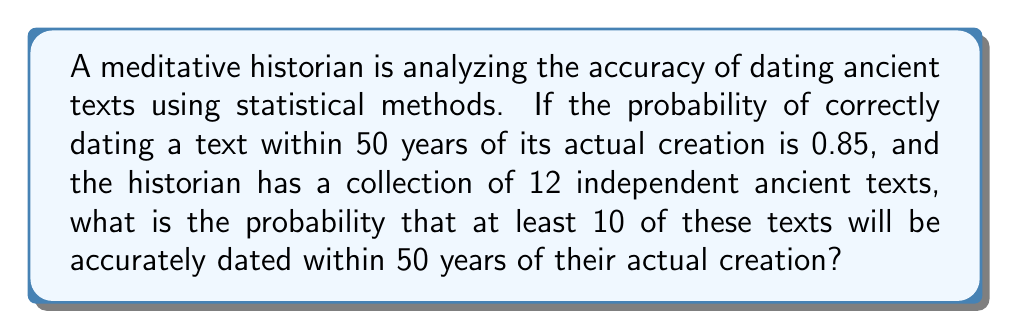Solve this math problem. Let's approach this step-by-step:

1) We can model this situation using a binomial distribution, where:
   - $n = 12$ (number of texts)
   - $p = 0.85$ (probability of success for each text)
   - We want to find $P(X \geq 10)$, where $X$ is the number of accurately dated texts

2) The probability of at least 10 successes is equal to 1 minus the probability of 9 or fewer successes:

   $P(X \geq 10) = 1 - P(X \leq 9)$

3) We can calculate this using the cumulative binomial probability function:

   $P(X \geq 10) = 1 - \sum_{k=0}^9 \binom{12}{k} (0.85)^k (0.15)^{12-k}$

4) Let's calculate this step-by-step:

   $\binom{12}{0} (0.85)^0 (0.15)^{12} = 8.7791 \times 10^{-10}$
   $\binom{12}{1} (0.85)^1 (0.15)^{11} = 1.8647 \times 10^{-8}$
   $\binom{12}{2} (0.85)^2 (0.15)^{10} = 1.8647 \times 10^{-7}$
   $\binom{12}{3} (0.85)^3 (0.15)^{9} = 1.1188 \times 10^{-6}$
   $\binom{12}{4} (0.85)^4 (0.15)^{8} = 4.4753 \times 10^{-6}$
   $\binom{12}{5} (0.85)^5 (0.15)^{7} = 1.2687 \times 10^{-5}$
   $\binom{12}{6} (0.85)^6 (0.15)^{6} = 2.5374 \times 10^{-5}$
   $\binom{12}{7} (0.85)^7 (0.15)^{5} = 3.5524 \times 10^{-5}$
   $\binom{12}{8} (0.85)^8 (0.15)^{4} = 3.3618 \times 10^{-5}$
   $\binom{12}{9} (0.85)^9 (0.15)^{3} = 2.0171 \times 10^{-5}$

5) Sum these probabilities:

   $\sum_{k=0}^9 \binom{12}{k} (0.85)^k (0.15)^{12-k} = 0.0001333$

6) Therefore:

   $P(X \geq 10) = 1 - 0.0001333 = 0.9998667$
Answer: 0.9998667 